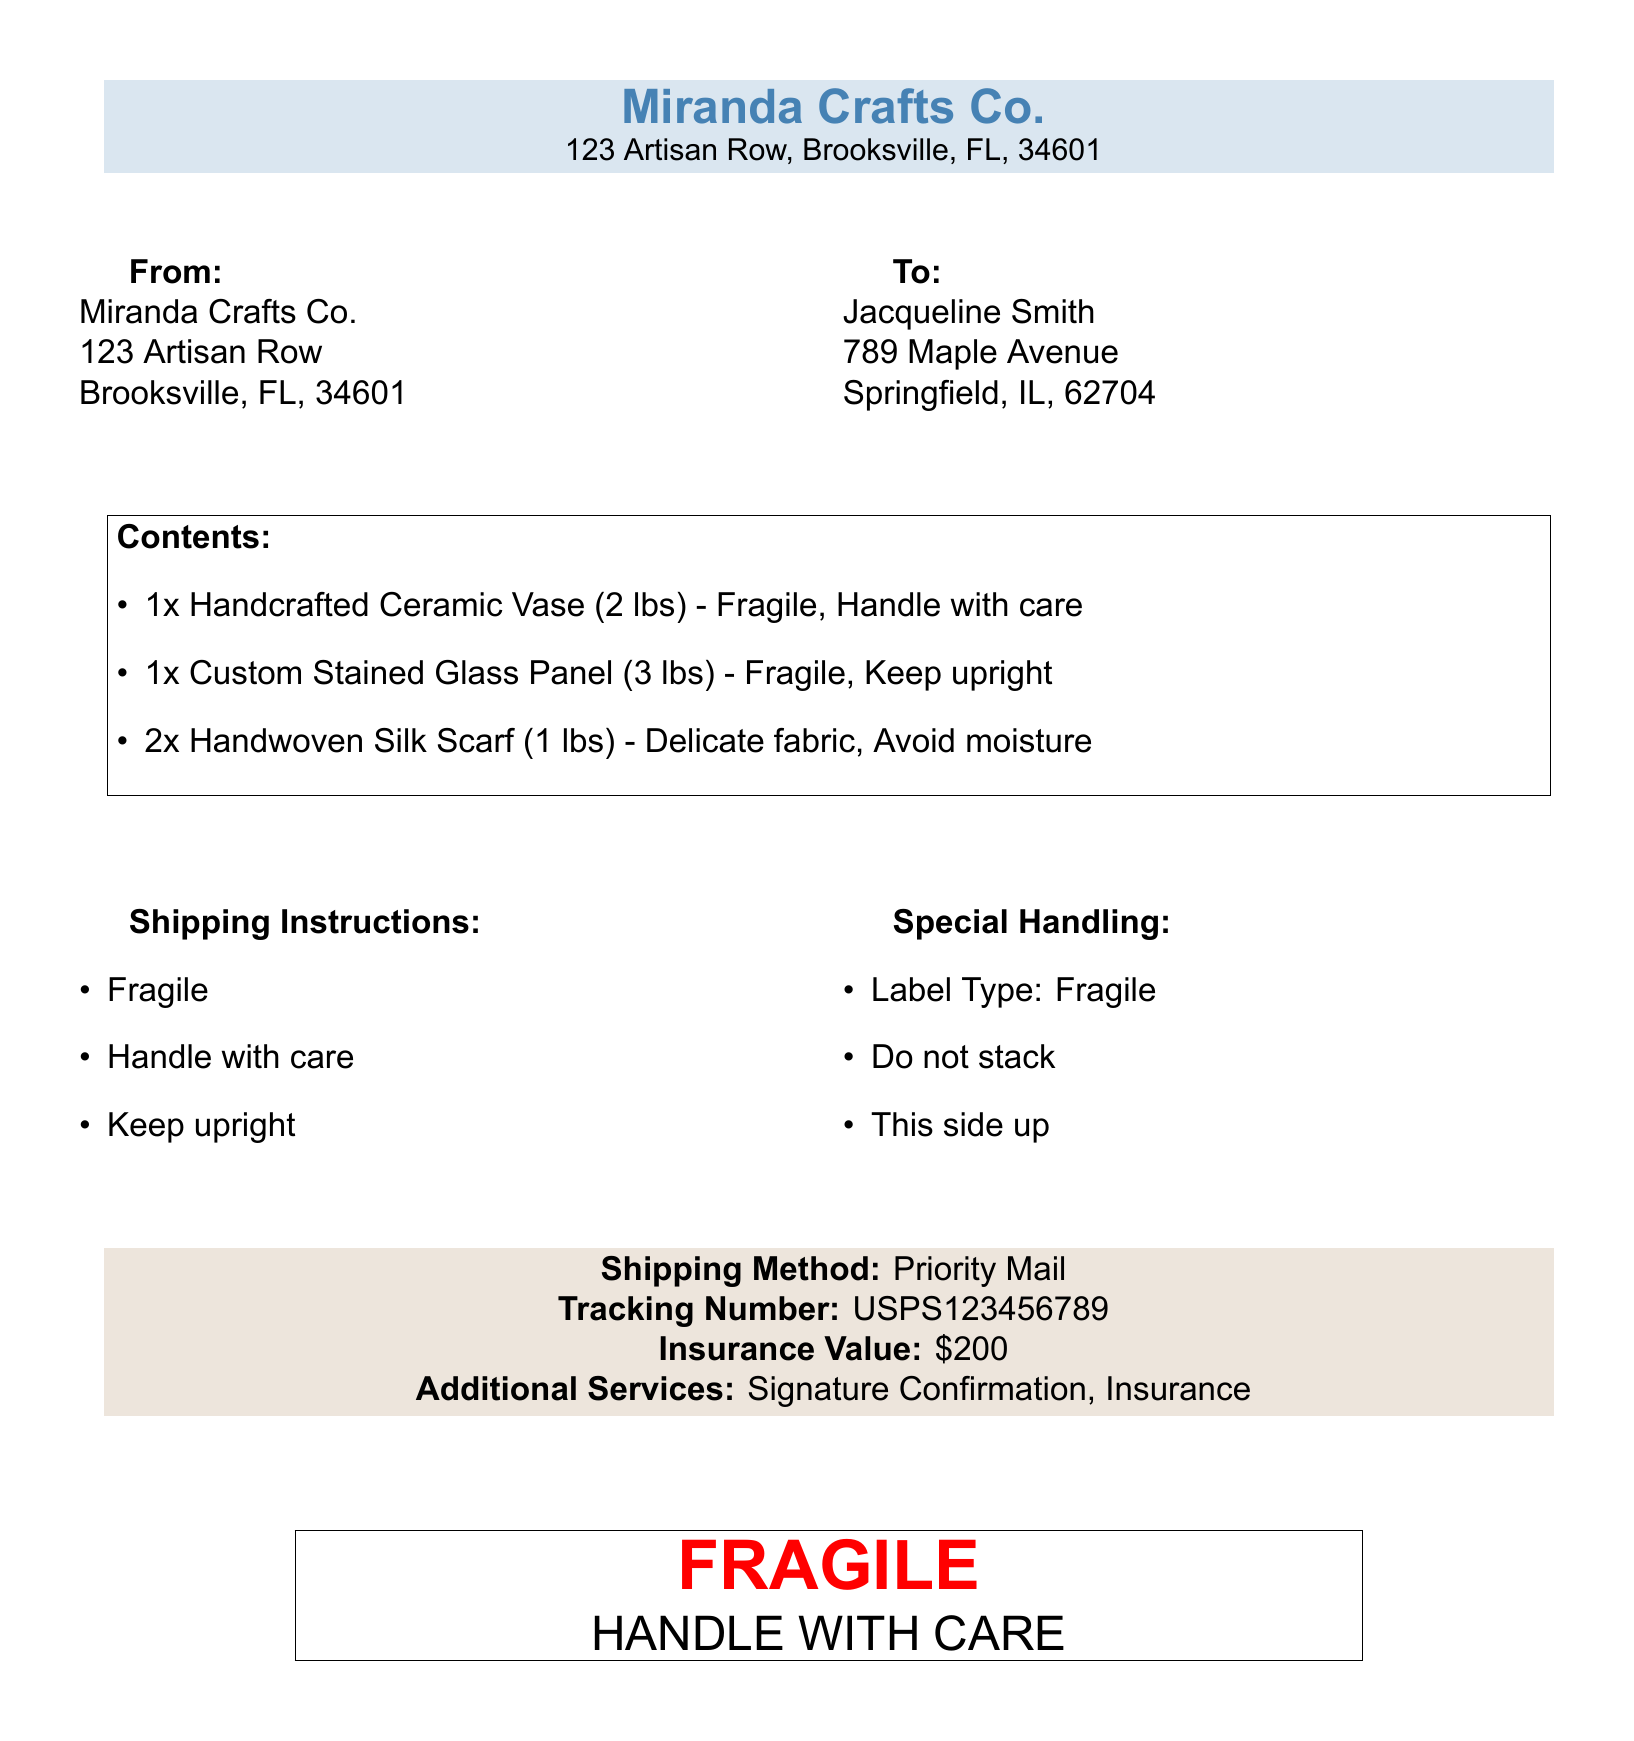What is the sender's name? The sender's name is Miranda Crafts Co., as indicated at the top of the document.
Answer: Miranda Crafts Co What is the recipient's address? The recipient's address is detailed under "To" on the label, providing their name and full address.
Answer: 789 Maple Avenue, Springfield, IL, 62704 How many items are listed in the contents? The contents section details the number of items, which are clearly itemized in a list.
Answer: 4 What is the tracking number associated with this package? The tracking number is specifically mentioned near the shipping method section in the document.
Answer: USPS123456789 What is the insurance value of the package? The insurance value is stated in the document within the shipping details section.
Answer: $200 Why must the custom stained glass panel be kept upright? This detail is specified in the contents list, providing the handling instruction for that item.
Answer: Keep upright What special handling instruction is given for the items? The special handling instructions are outlined in a separate section, detailing specific care requirements.
Answer: Fragile What shipping method is used for this package? The shipping method is mentioned toward the bottom of the document.
Answer: Priority Mail What should not be done with the package? The document includes specific instructions to prevent mishandling of the items during shipping.
Answer: Do not stack 